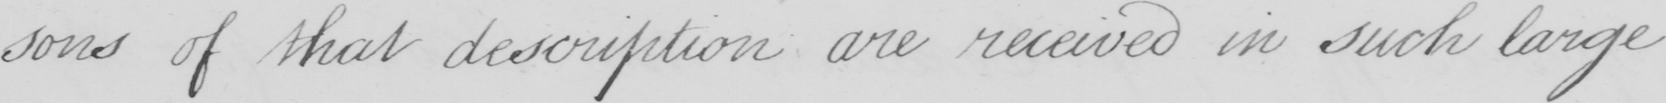What text is written in this handwritten line? -sons of that description are received in such large 